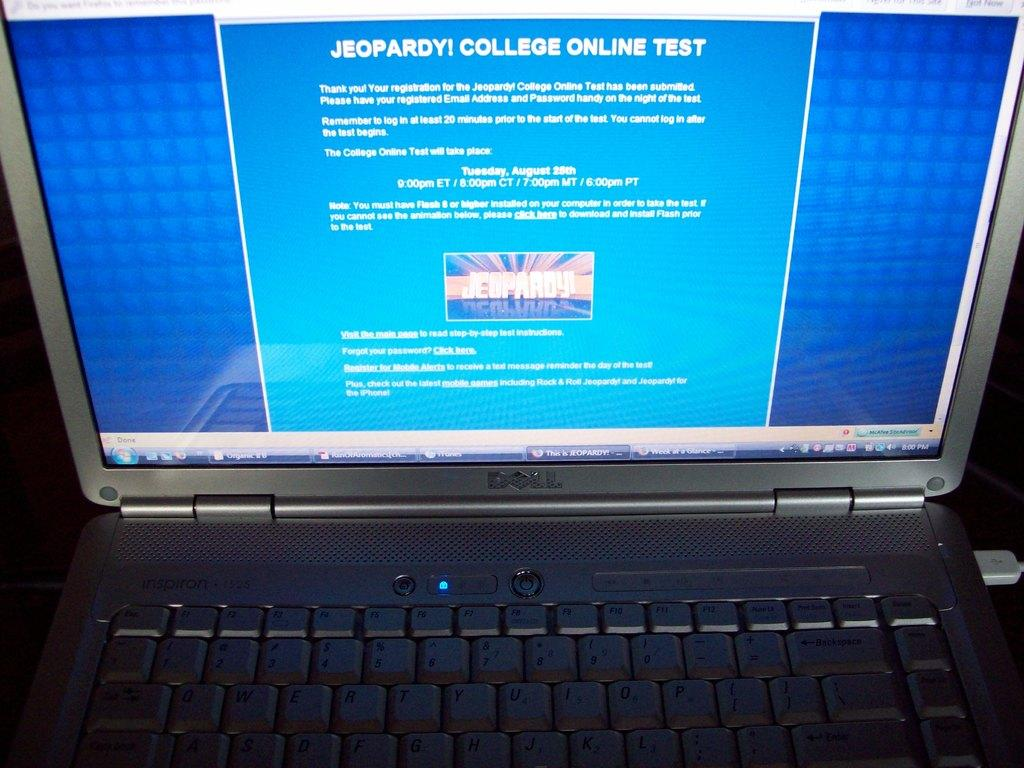<image>
Provide a brief description of the given image. A Dell laptop with a page pulled up displaying the Jeopardy! College Online Test 